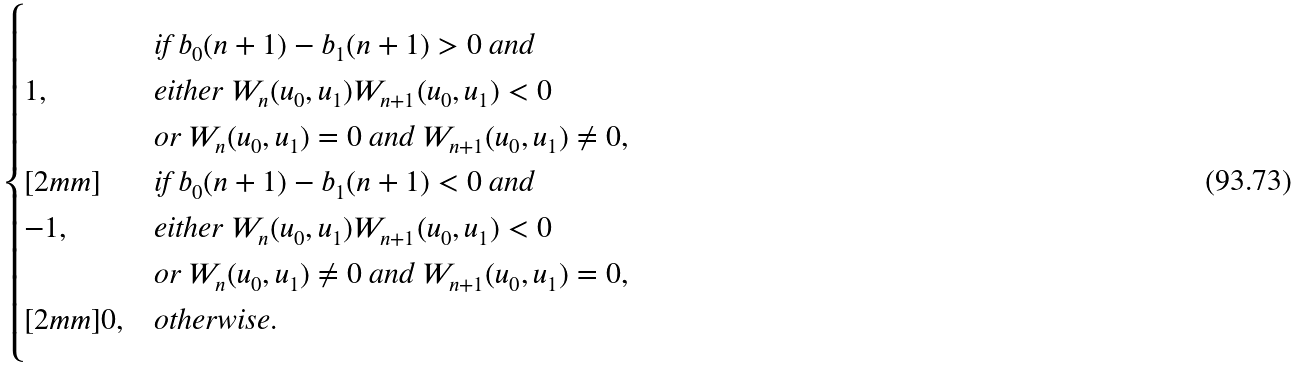<formula> <loc_0><loc_0><loc_500><loc_500>\begin{cases} & \text {if } b _ { 0 } ( n + 1 ) - b _ { 1 } ( n + 1 ) > 0 \text { and } \\ 1 , & \text {either } W _ { n } ( u _ { 0 } , u _ { 1 } ) W _ { n + 1 } ( u _ { 0 } , u _ { 1 } ) < 0 \\ & \text {or } W _ { n } ( u _ { 0 } , u _ { 1 } ) = 0 \text { and } W _ { n + 1 } ( u _ { 0 } , u _ { 1 } ) \neq 0 , \\ [ 2 m m ] & \text {if } b _ { 0 } ( n + 1 ) - b _ { 1 } ( n + 1 ) < 0 \text { and } \\ - 1 , & \text {either } W _ { n } ( u _ { 0 } , u _ { 1 } ) W _ { n + 1 } ( u _ { 0 } , u _ { 1 } ) < 0 \\ & \text {or } W _ { n } ( u _ { 0 } , u _ { 1 } ) \neq 0 \text { and } W _ { n + 1 } ( u _ { 0 } , u _ { 1 } ) = 0 , \\ [ 2 m m ] 0 , & \text {otherwise} . \end{cases}</formula> 